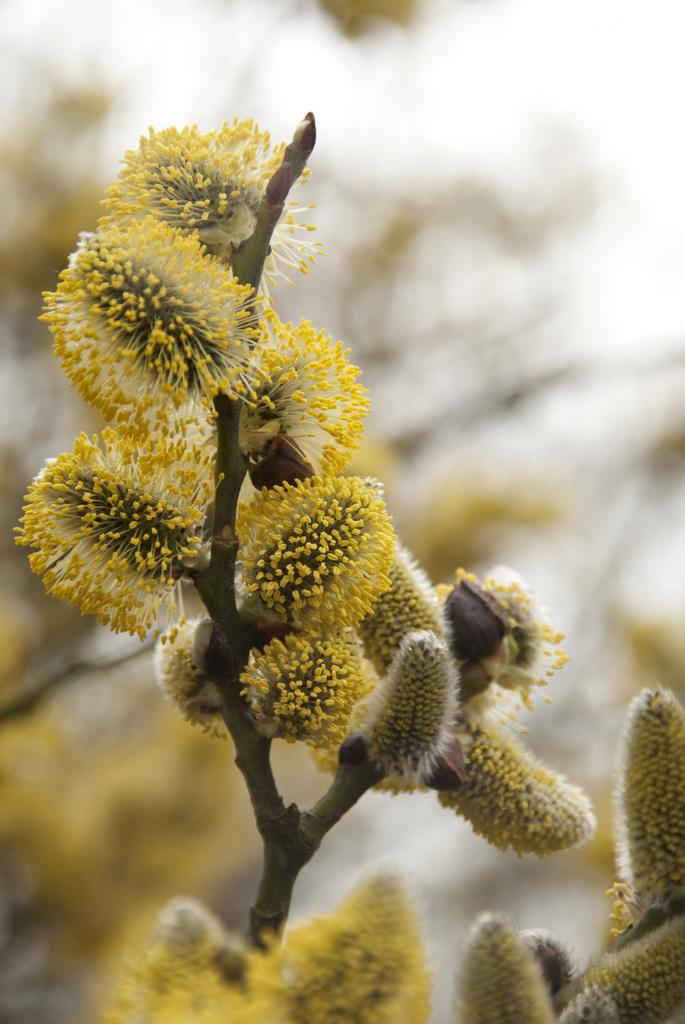What is the main subject of the image? There is a tree in the image. What can be observed about the tree's flowers? The tree has yellow and cream-colored flowers. What else can be seen in the background of the image? There are other trees visible in the background of the image. How is the sky depicted in the image? The sky is visible in the background of the image, but it is blurry. How far can the fly travel in the image? There is no fly present in the image, so it is not possible to determine how far it could travel. 